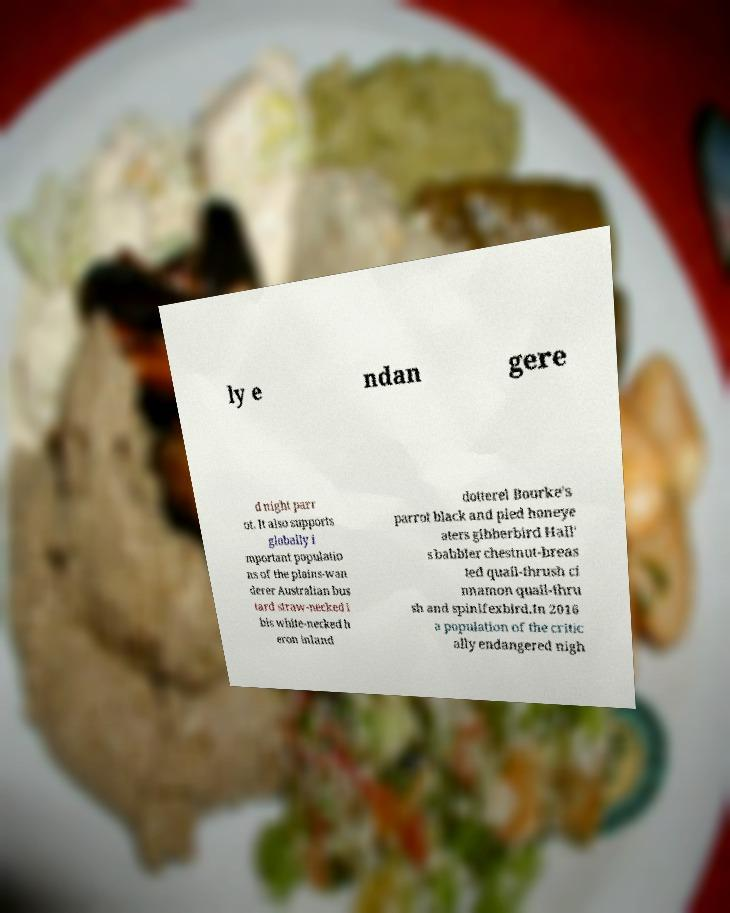Could you extract and type out the text from this image? ly e ndan gere d night parr ot. It also supports globally i mportant populatio ns of the plains-wan derer Australian bus tard straw-necked i bis white-necked h eron inland dotterel Bourke's parrot black and pied honeye aters gibberbird Hall' s babbler chestnut-breas ted quail-thrush ci nnamon quail-thru sh and spinifexbird.In 2016 a population of the critic ally endangered nigh 